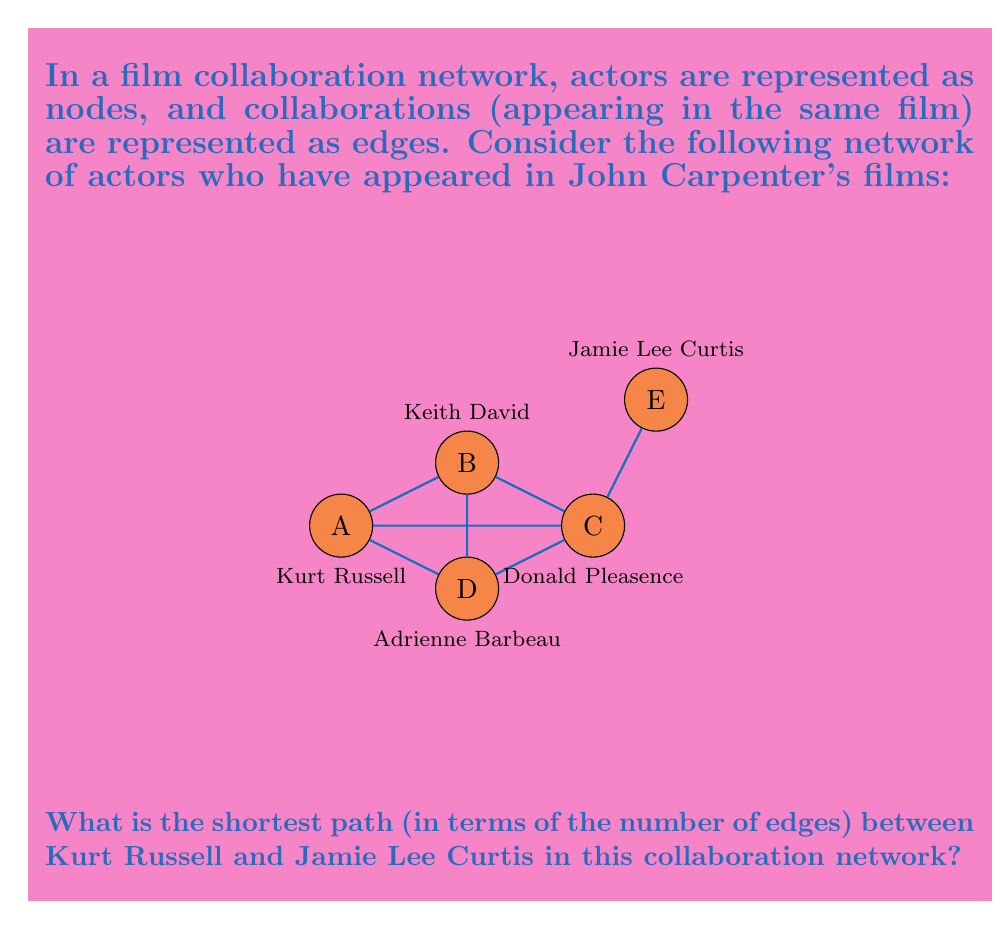Teach me how to tackle this problem. To solve this problem, we need to apply the concept of shortest path in graph theory. Here's a step-by-step approach:

1) First, let's identify the starting and ending nodes:
   - Starting node: Kurt Russell (A)
   - Ending node: Jamie Lee Curtis (E)

2) Now, let's explore all possible paths from A to E:

   Path 1: A → B → C → E
   Path 2: A → C → E
   Path 3: A → D → C → E

3) To determine the shortest path, we count the number of edges in each path:

   Path 1: 3 edges
   Path 2: 2 edges
   Path 3: 3 edges

4) The shortest path is the one with the fewest edges, which is Path 2: A → C → E.

5) This path represents:
   Kurt Russell → Donald Pleasence → Jamie Lee Curtis

6) The length of this shortest path is 2, meaning Kurt Russell and Jamie Lee Curtis are separated by 2 degrees in this John Carpenter film collaboration network.

In graph theory terms, we've found that the distance $d(A,E) = 2$, where $d(x,y)$ represents the shortest path distance between nodes $x$ and $y$.
Answer: 2 